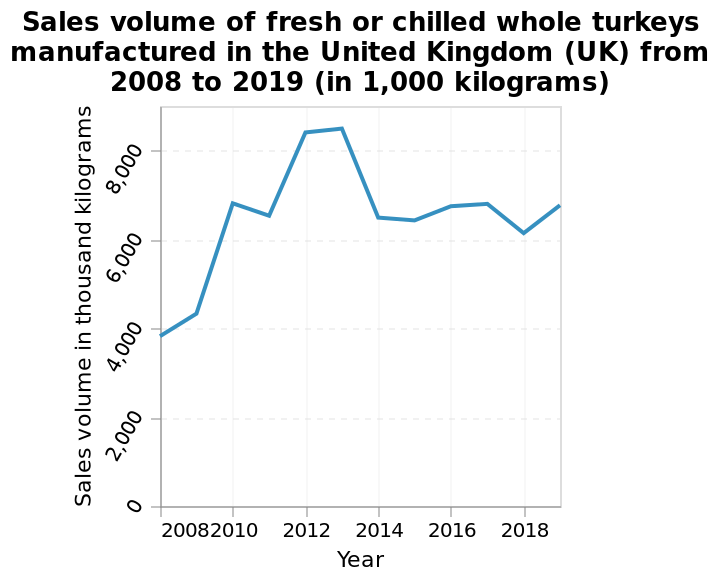<image>
please enumerates aspects of the construction of the chart This line plot is named Sales volume of fresh or chilled whole turkeys manufactured in the United Kingdom (UK) from 2008 to 2019 (in 1,000 kilograms). On the y-axis, Sales volume in thousand kilograms is drawn. On the x-axis, Year is measured on a linear scale from 2008 to 2018. Is the line plot named Sales volume of fresh or chilled whole turkeys manufactured in the United Kingdom (UK) from 2008 to 2019 (in 1,000 pounds)? No.This line plot is named Sales volume of fresh or chilled whole turkeys manufactured in the United Kingdom (UK) from 2008 to 2019 (in 1,000 kilograms). On the y-axis, Sales volume in thousand kilograms is drawn. On the x-axis, Year is measured on a linear scale from 2008 to 2018. 